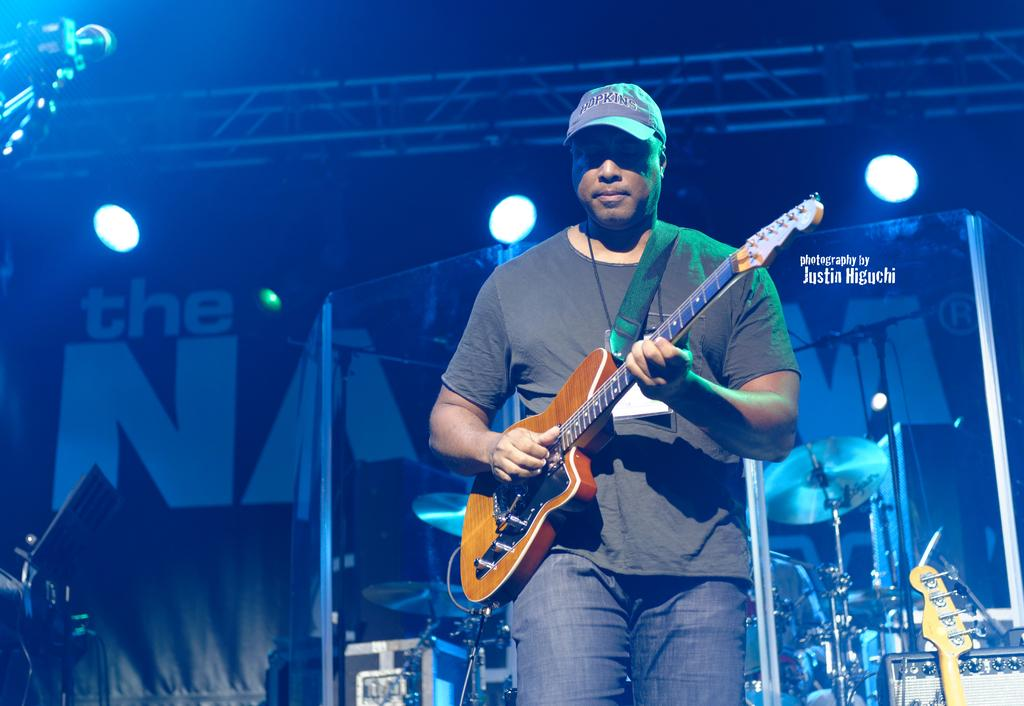Who is the person in the image? There is a man in the image. What is the man wearing on his head? The man is wearing a hat. What color is the man's t-shirt? The man is wearing a black t-shirt. What is the man doing in the image? The man is playing a guitar. Where is the man performing? The man is on a stage. What type of quill is the man using to write on the wheel in the image? There is no quill or wheel present in the image; the man is playing a guitar on a stage. 